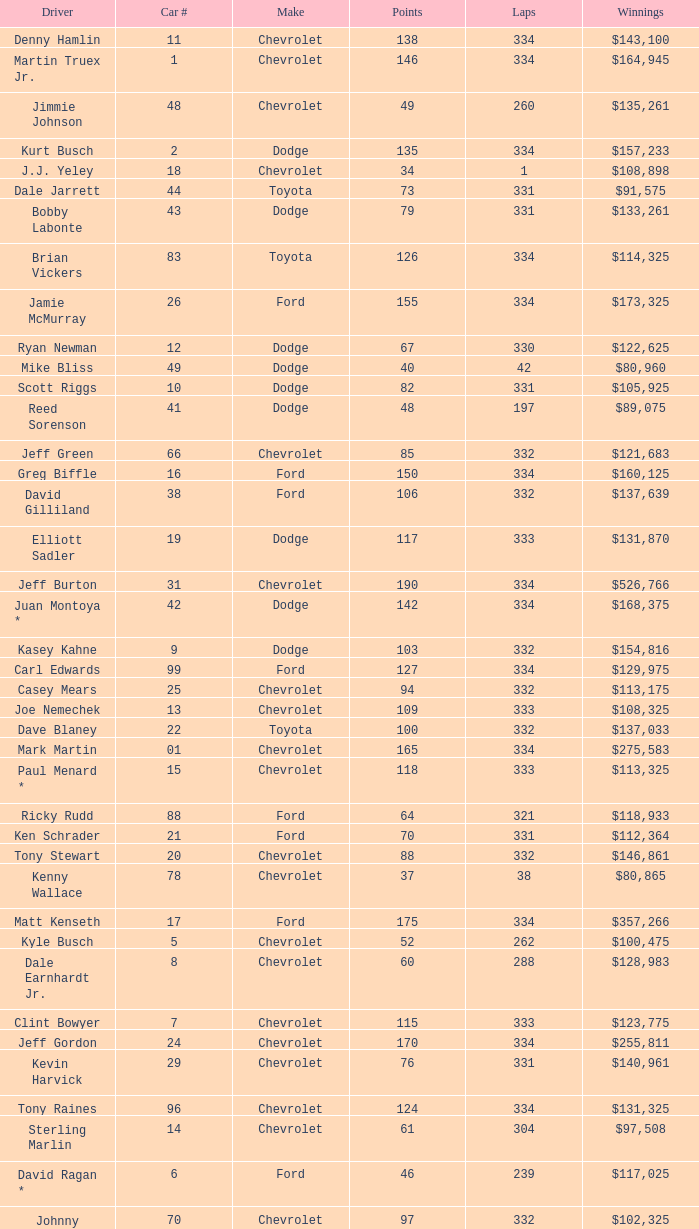How many total laps did the Chevrolet that won $97,508 make? 1.0. 